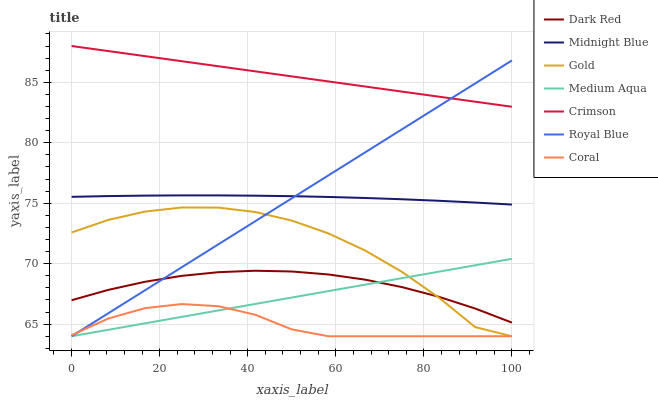Does Coral have the minimum area under the curve?
Answer yes or no. Yes. Does Crimson have the maximum area under the curve?
Answer yes or no. Yes. Does Gold have the minimum area under the curve?
Answer yes or no. No. Does Gold have the maximum area under the curve?
Answer yes or no. No. Is Crimson the smoothest?
Answer yes or no. Yes. Is Gold the roughest?
Answer yes or no. Yes. Is Dark Red the smoothest?
Answer yes or no. No. Is Dark Red the roughest?
Answer yes or no. No. Does Gold have the lowest value?
Answer yes or no. Yes. Does Dark Red have the lowest value?
Answer yes or no. No. Does Crimson have the highest value?
Answer yes or no. Yes. Does Gold have the highest value?
Answer yes or no. No. Is Midnight Blue less than Crimson?
Answer yes or no. Yes. Is Crimson greater than Gold?
Answer yes or no. Yes. Does Royal Blue intersect Gold?
Answer yes or no. Yes. Is Royal Blue less than Gold?
Answer yes or no. No. Is Royal Blue greater than Gold?
Answer yes or no. No. Does Midnight Blue intersect Crimson?
Answer yes or no. No. 